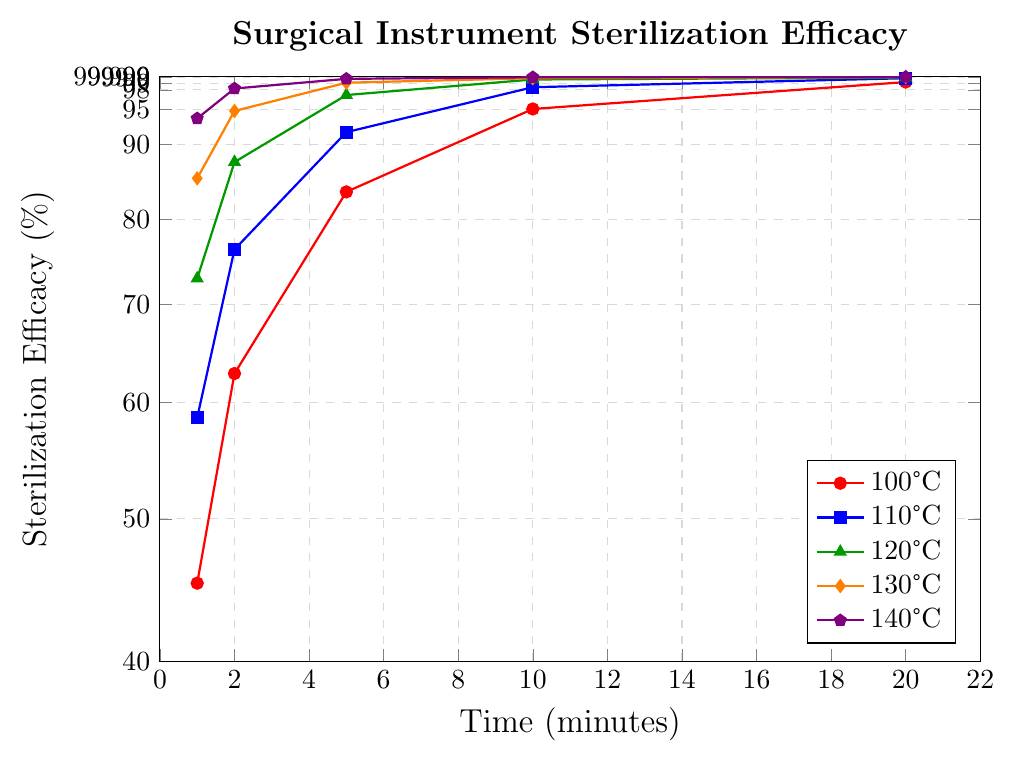Which temperature achieves over 99.0% sterilization efficacy the quickest? To determine which temperature reaches over 99.0% efficacy the fastest, inspect the plots to see which line first crosses the 99.0% threshold. The 130°C plot crosses it at 5 minutes, and the 140°C plot does so between 2 and 5 minutes.
Answer: 140°C At 100°C, how much does sterilization efficacy increase from 1 minute to 10 minutes? Find the sterilization efficacy at 1 minute (45.2%) and at 10 minutes (95.1%) for 100°C. Calculate the increase: 95.1% - 45.2% = 49.9%.
Answer: 49.9% Compare the sterilization efficacy at 120°C and 130°C after 5 minutes. Which one is higher? Locate the efficacy values for 120°C and 130°C at the 5-minute mark. For 120°C, it is 97.2%. For 130°C, it is 99.1%. Since 99.1% is greater than 97.2%, 130°C has higher efficacy after 5 minutes.
Answer: 130°C What is the average sterilization efficacy at 140°C over all given time intervals? The given efficacy values at 140°C are: 93.7%, 98.2%, 99.7%, 99.95%, 99.999%. Calculate the average: (93.7 + 98.2 + 99.7 + 99.95 + 99.999)/5 = 98.7098%.
Answer: 98.71% By how much does sterilization efficacy at 1 minute increase from 100°C to 140°C? Find the sterilization efficacy at 1 minute for 100°C (45.2%) and 1 minute for 140°C (93.7%). Calculate the increase: 93.7% - 45.2% = 48.5%.
Answer: 48.5% Which color represents the data series for 110°C, and what is its efficacy at 10 minutes? Identify the color associated with 110°C from the legend. The color is blue. Check the efficacy at 10 minutes for 110°C, which is 98.4%.
Answer: Blue, 98.4% After how many minutes does sterilization efficacy exceed 95% at 120°C? Inspect the 120°C plot and find where it first crosses the 95% threshold. It crosses at 5 minutes.
Answer: 5 minutes What's the difference in sterilization efficacy between 100°C and 120°C at 5 minutes? Find the efficacy at 5 minutes for 100°C (83.5%) and 120°C (97.2%). Calculate the difference: 97.2% - 83.5% = 13.7%.
Answer: 13.7% Which temperature shows the smallest change in efficacy between 10 and 20 minutes? Calculate the change in efficacy for each temperature between 10 and 20 minutes. Smaller changes are more gradual:
- 100°C: 99.2% - 95.1% = 4.1%
- 110°C: 99.8% - 98.4% = 1.4%
- 120°C: 99.9% - 99.6% = 0.3%
- 130°C: 99.99% - 99.8% = 0.19%
- 140°C: 99.999% - 99.95% = 0.049%
130°C shows the smallest change in efficacy.
Answer: 130°C 